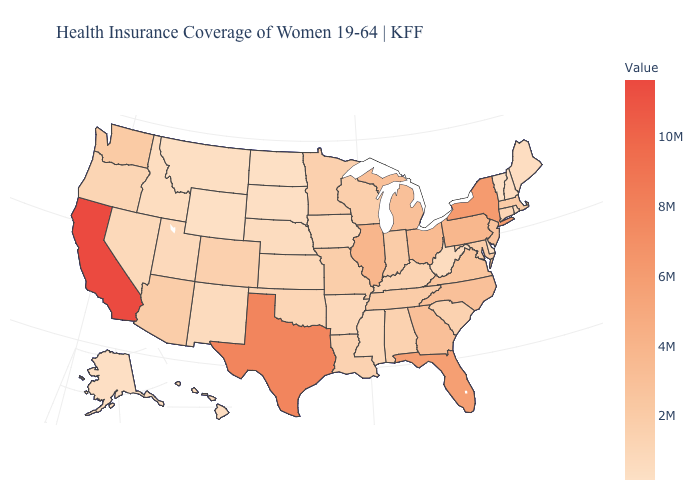Among the states that border Kentucky , does West Virginia have the lowest value?
Be succinct. Yes. Is the legend a continuous bar?
Give a very brief answer. Yes. Is the legend a continuous bar?
Give a very brief answer. Yes. Among the states that border Vermont , does New Hampshire have the lowest value?
Give a very brief answer. Yes. Which states have the highest value in the USA?
Give a very brief answer. California. Is the legend a continuous bar?
Short answer required. Yes. Does the map have missing data?
Keep it brief. No. 